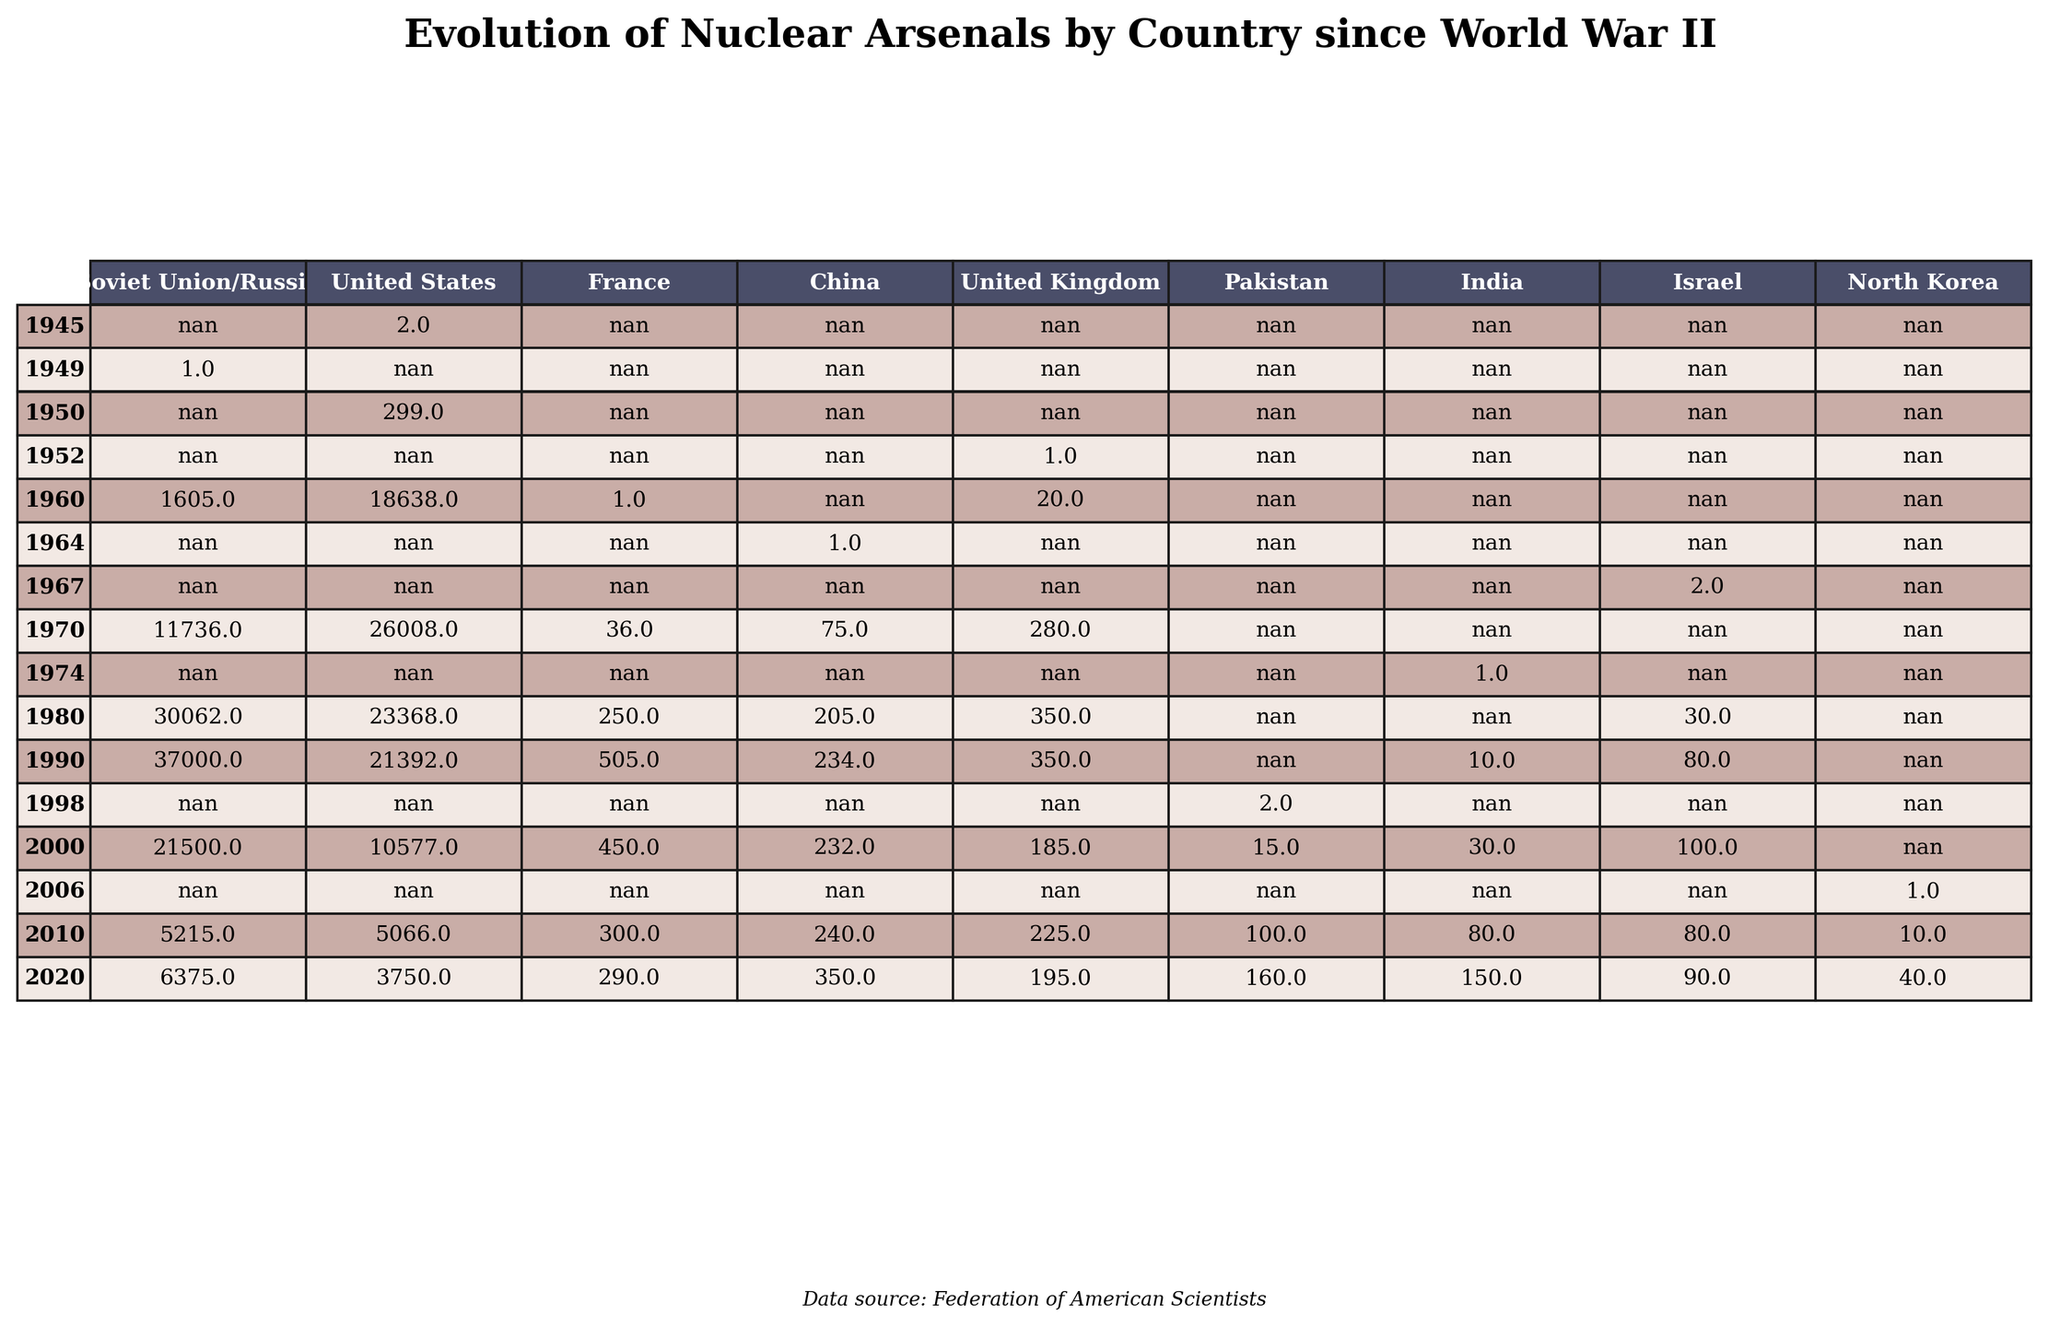What year did the United Kingdom first possess nuclear warheads? The UK first developed nuclear warheads in 1952, as indicated in the table.
Answer: 1952 Which country had the highest number of nuclear warheads in 1990? According to the table, in 1990, the Soviet Union had the highest number of nuclear warheads with 37,000.
Answer: Soviet Union What was the percentage decrease in nuclear warheads for the United States from 1990 to 2020? In 1990, the US had 21,392 warheads, and by 2020, it had 3,750. The decrease is 21,392 - 3,750 = 17,642. The percentage decrease is (17,642 / 21,392) × 100 ≈ 82.5%.
Answer: Approximately 82.5% Did France ever surpass the United Kingdom in the number of nuclear warheads? In the table, France's peak was 505 nuclear warheads in 1990, while the UK's peak was 350. So, yes, France did surpass the UK.
Answer: Yes What is the total number of nuclear warheads possessed by China from 1964 to 2020? To find the total, we sum the values for China across the years: 1 + 75 + 205 + 234 + 232 + 240 + 350 = 1,097.
Answer: 1,097 Which country had a nuclear arsenal in 1960 but did not have one in 1945? The table shows that the Soviet Union had nuclear warheads in 1949 but not in 1945; therefore, it fits this description.
Answer: Soviet Union What was the average number of nuclear warheads for India from 1974 to 2020? The values for India are: 1 (1974), 10 (1990), 30 (2000), 80 (2010), 150 (2020). Summing these gives 271, and there are 5 data points, so the average is 271 / 5 = 54.2.
Answer: 54.2 Which country had the lowest count of nuclear warheads in 2020? The table shows that both North Korea and Israel had low counts, but North Korea has only 40 compared to Israel's 90 in 2020. Thus, North Korea had the lowest.
Answer: North Korea How many more nuclear warheads did the Soviet Union/Russia have in 1980 compared to France in the same year? In 1980, the Soviet Union had 30,062 warheads and France had 250, so the difference is 30,062 - 250 = 29,812.
Answer: 29,812 What was the trend in the number of nuclear warheads for the United States from 1980 to 2020? The number decreased from 23,368 in 1980 to 3,750 in 2020, showing a clear downward trend over these years.
Answer: Decreasing trend 